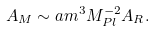Convert formula to latex. <formula><loc_0><loc_0><loc_500><loc_500>A _ { M } \sim a m ^ { 3 } M _ { P l } ^ { - 2 } A _ { R } .</formula> 